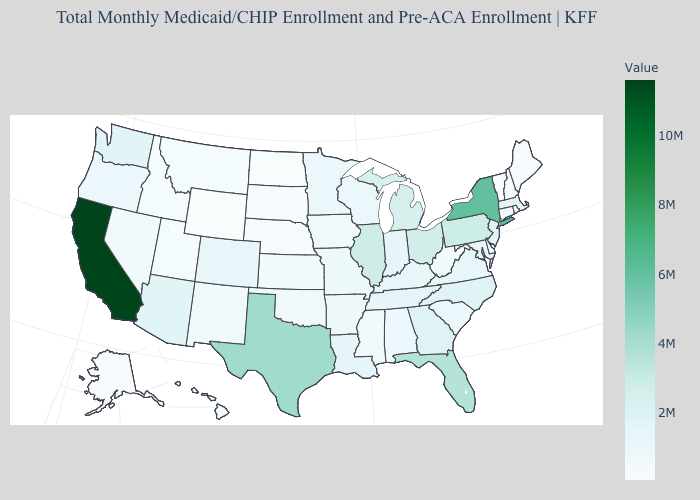Among the states that border Delaware , which have the lowest value?
Keep it brief. Maryland. Among the states that border Pennsylvania , does Delaware have the lowest value?
Short answer required. Yes. Does Connecticut have the lowest value in the Northeast?
Give a very brief answer. No. Does Utah have the highest value in the West?
Answer briefly. No. Among the states that border Alabama , which have the lowest value?
Concise answer only. Mississippi. Does Alaska have a higher value than California?
Write a very short answer. No. 